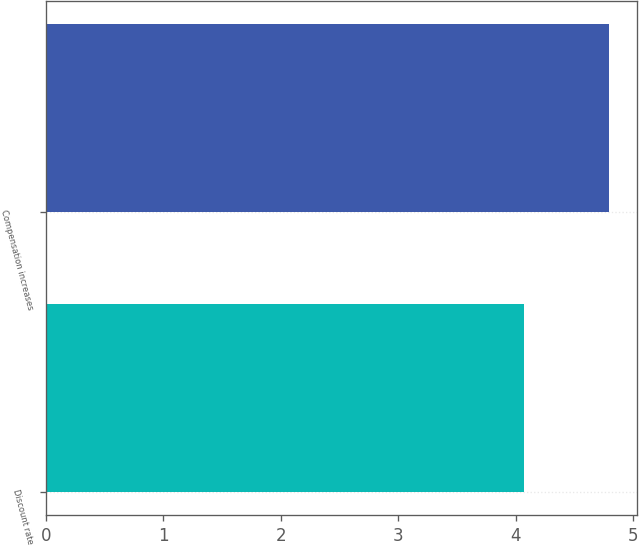<chart> <loc_0><loc_0><loc_500><loc_500><bar_chart><fcel>Discount rate<fcel>Compensation increases<nl><fcel>4.07<fcel>4.79<nl></chart> 